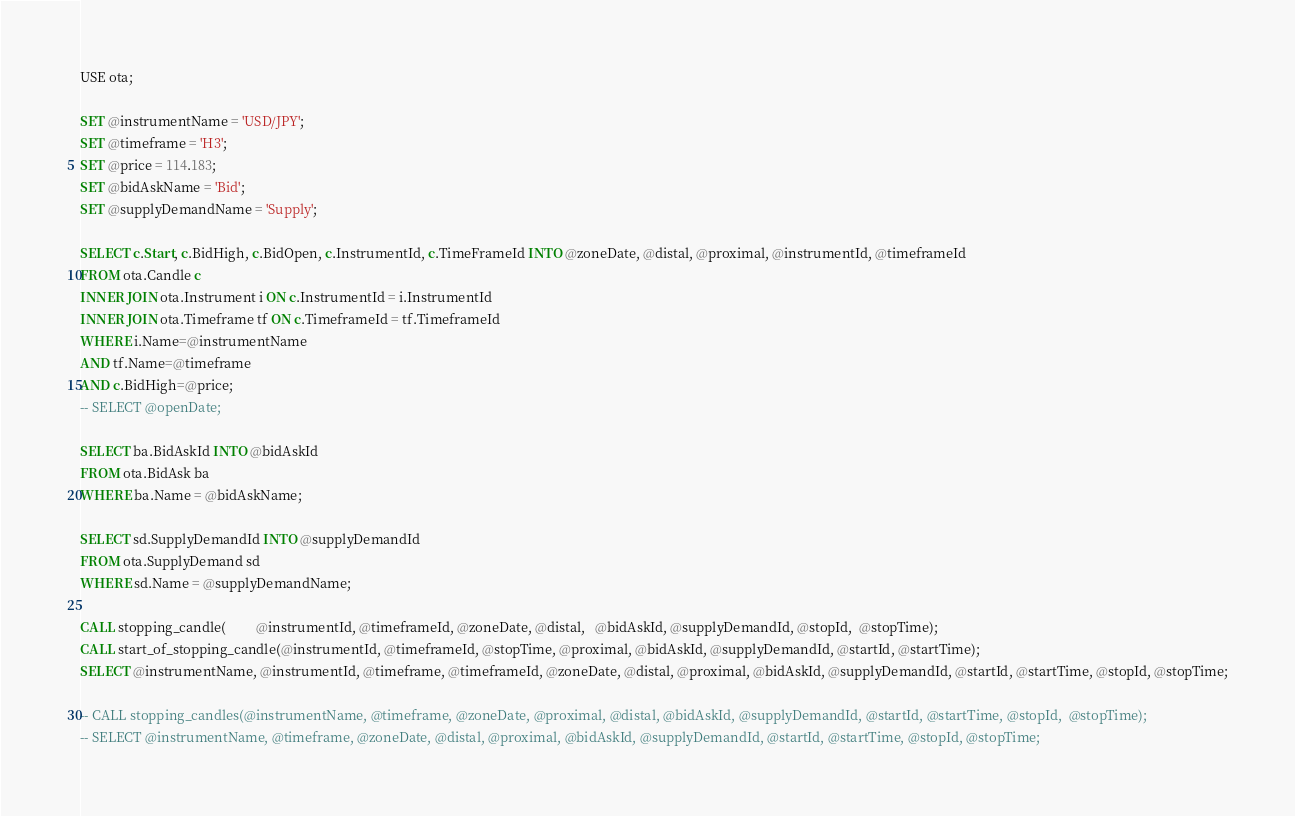Convert code to text. <code><loc_0><loc_0><loc_500><loc_500><_SQL_>USE ota;

SET @instrumentName = 'USD/JPY';
SET @timeframe = 'H3';
SET @price = 114.183;
SET @bidAskName = 'Bid';
SET @supplyDemandName = 'Supply';

SELECT c.Start, c.BidHigh, c.BidOpen, c.InstrumentId, c.TimeFrameId INTO @zoneDate, @distal, @proximal, @instrumentId, @timeframeId
FROM ota.Candle c
INNER JOIN ota.Instrument i ON c.InstrumentId = i.InstrumentId
INNER JOIN ota.Timeframe tf ON c.TimeframeId = tf.TimeframeId
WHERE i.Name=@instrumentName
AND tf.Name=@timeframe
AND c.BidHigh=@price;
-- SELECT @openDate;

SELECT ba.BidAskId INTO @bidAskId
FROM ota.BidAsk ba
WHERE ba.Name = @bidAskName;

SELECT sd.SupplyDemandId INTO @supplyDemandId
FROM ota.SupplyDemand sd
WHERE sd.Name = @supplyDemandName;

CALL stopping_candle(         @instrumentId, @timeframeId, @zoneDate, @distal,   @bidAskId, @supplyDemandId, @stopId,  @stopTime);
CALL start_of_stopping_candle(@instrumentId, @timeframeId, @stopTime, @proximal, @bidAskId, @supplyDemandId, @startId, @startTime);
SELECT @instrumentName, @instrumentId, @timeframe, @timeframeId, @zoneDate, @distal, @proximal, @bidAskId, @supplyDemandId, @startId, @startTime, @stopId, @stopTime;

-- CALL stopping_candles(@instrumentName, @timeframe, @zoneDate, @proximal, @distal, @bidAskId, @supplyDemandId, @startId, @startTime, @stopId,  @stopTime);
-- SELECT @instrumentName, @timeframe, @zoneDate, @distal, @proximal, @bidAskId, @supplyDemandId, @startId, @startTime, @stopId, @stopTime;
</code> 